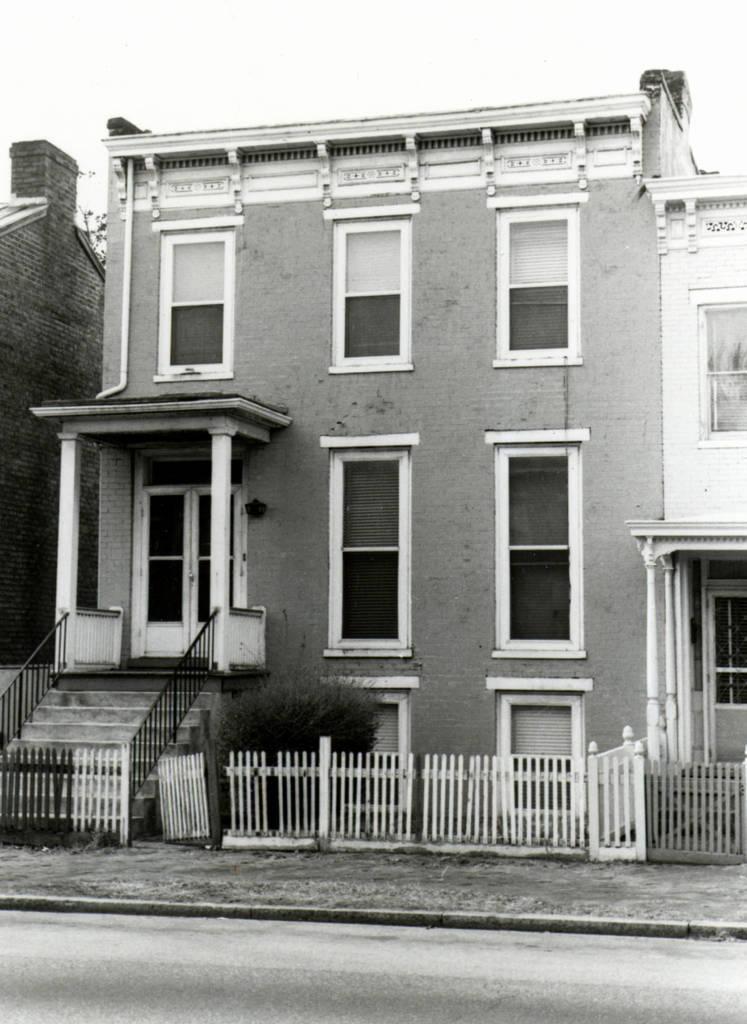Please provide a concise description of this image. I can see this is a black and white picture. There are buildings, pillars, stairs, staircase holders and there is fencing. In the background there is sky. 